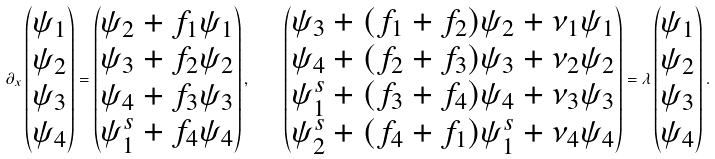Convert formula to latex. <formula><loc_0><loc_0><loc_500><loc_500>\partial _ { x } \begin{pmatrix} \psi _ { 1 } \\ \psi _ { 2 } \\ \psi _ { 3 } \\ \psi _ { 4 } \end{pmatrix} = \begin{pmatrix} \psi _ { 2 } + f _ { 1 } \psi _ { 1 } \\ \psi _ { 3 } + f _ { 2 } \psi _ { 2 } \\ \psi _ { 4 } + f _ { 3 } \psi _ { 3 } \\ \psi _ { 1 } ^ { s } + f _ { 4 } \psi _ { 4 } \end{pmatrix} , \quad \begin{pmatrix} \psi _ { 3 } + ( f _ { 1 } + f _ { 2 } ) \psi _ { 2 } + \nu _ { 1 } \psi _ { 1 } \\ \psi _ { 4 } + ( f _ { 2 } + f _ { 3 } ) \psi _ { 3 } + \nu _ { 2 } \psi _ { 2 } \\ \psi _ { 1 } ^ { s } + ( f _ { 3 } + f _ { 4 } ) \psi _ { 4 } + \nu _ { 3 } \psi _ { 3 } \\ \psi _ { 2 } ^ { s } + ( f _ { 4 } + f _ { 1 } ) \psi _ { 1 } ^ { s } + \nu _ { 4 } \psi _ { 4 } \end{pmatrix} = \lambda \begin{pmatrix} \psi _ { 1 } \\ \psi _ { 2 } \\ \psi _ { 3 } \\ \psi _ { 4 } \end{pmatrix} .</formula> 